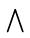Convert formula to latex. <formula><loc_0><loc_0><loc_500><loc_500>\bigwedge</formula> 